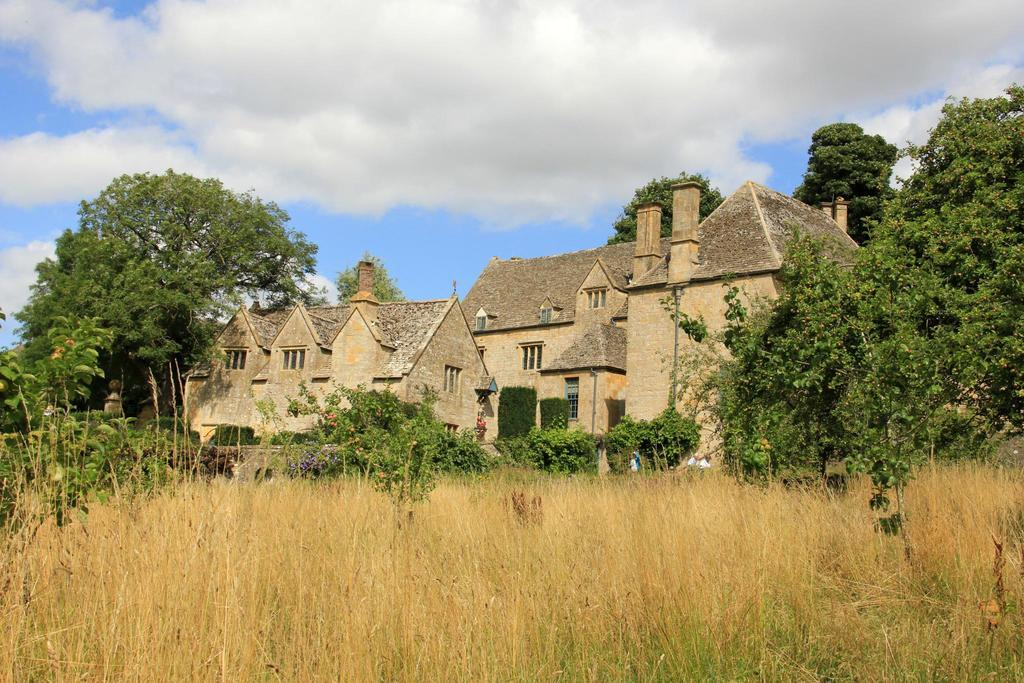What type of vegetation can be seen in the image? There is grass in the image. Are there any other natural elements present in the image? Yes, there are trees in the image. What type of structure is visible in the image? There is a house in the image. What color is the sky in the background of the image? The sky is blue in the background of the image. How many lead pipes can be seen in the image? There are no lead pipes present in the image. What type of coin is visible in the image? There is no coin, such as a dime, present in the image. 